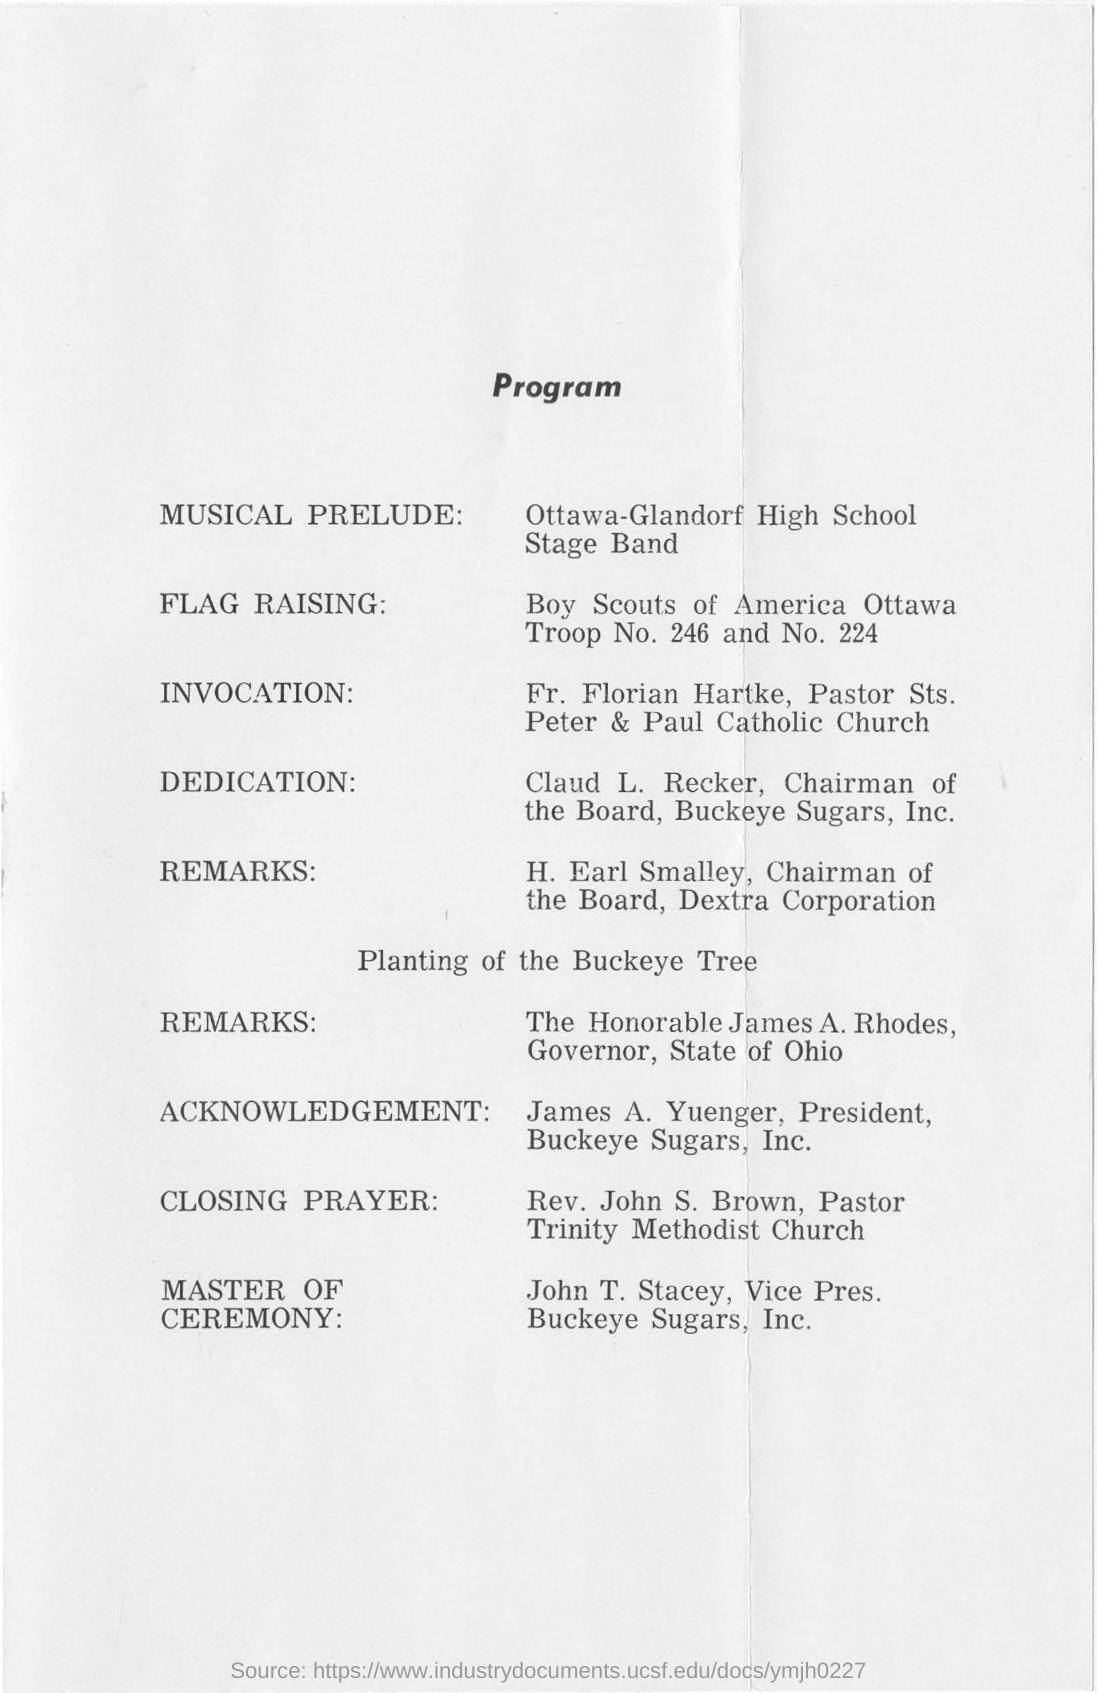Who is in the "Musical Prelude" ?
Keep it short and to the point. Ottawa-Glandorf High School Stage Band. Who is the Master of Ceremony as per the program schedule?
Give a very brief answer. John T. Stacey, Vice Pres. Buckeye Sugars, Inc. 